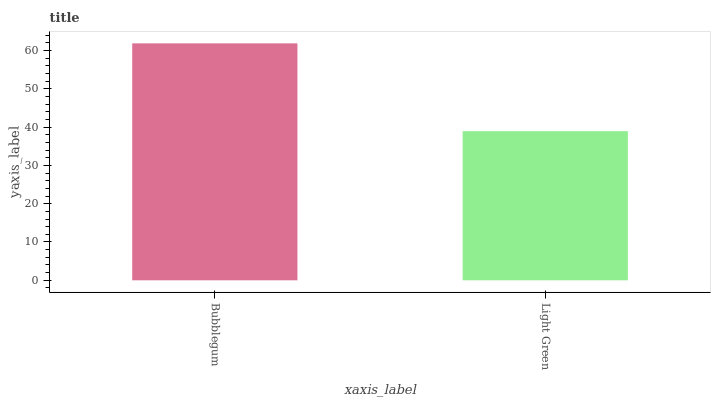Is Light Green the maximum?
Answer yes or no. No. Is Bubblegum greater than Light Green?
Answer yes or no. Yes. Is Light Green less than Bubblegum?
Answer yes or no. Yes. Is Light Green greater than Bubblegum?
Answer yes or no. No. Is Bubblegum less than Light Green?
Answer yes or no. No. Is Bubblegum the high median?
Answer yes or no. Yes. Is Light Green the low median?
Answer yes or no. Yes. Is Light Green the high median?
Answer yes or no. No. Is Bubblegum the low median?
Answer yes or no. No. 